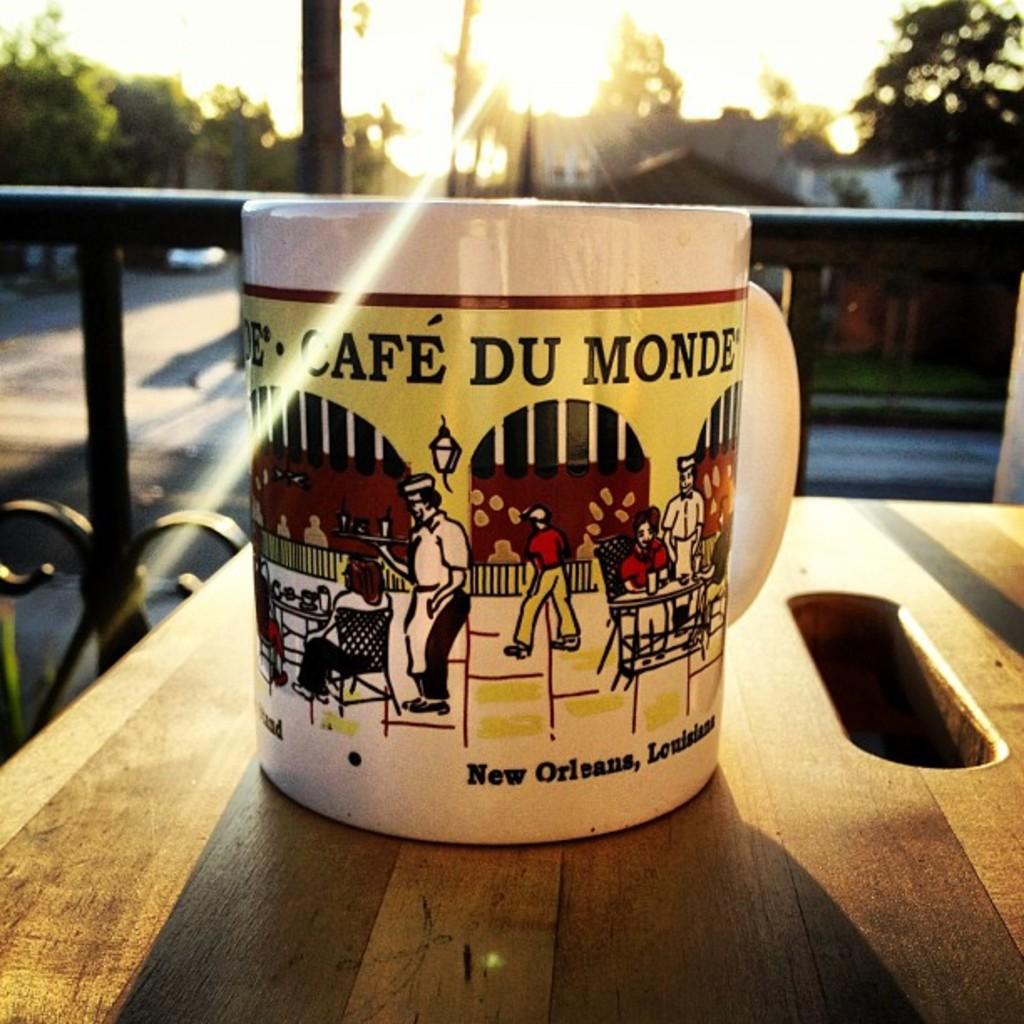Which american city does the mug come from?
Your answer should be very brief. New orleans. 